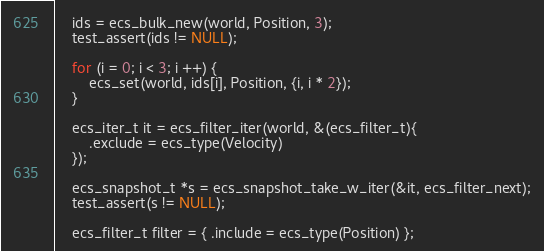Convert code to text. <code><loc_0><loc_0><loc_500><loc_500><_C_>    ids = ecs_bulk_new(world, Position, 3);
    test_assert(ids != NULL);

    for (i = 0; i < 3; i ++) {
        ecs_set(world, ids[i], Position, {i, i * 2});
    }    

    ecs_iter_t it = ecs_filter_iter(world, &(ecs_filter_t){
        .exclude = ecs_type(Velocity)
    });

    ecs_snapshot_t *s = ecs_snapshot_take_w_iter(&it, ecs_filter_next);
    test_assert(s != NULL);

    ecs_filter_t filter = { .include = ecs_type(Position) };
</code> 